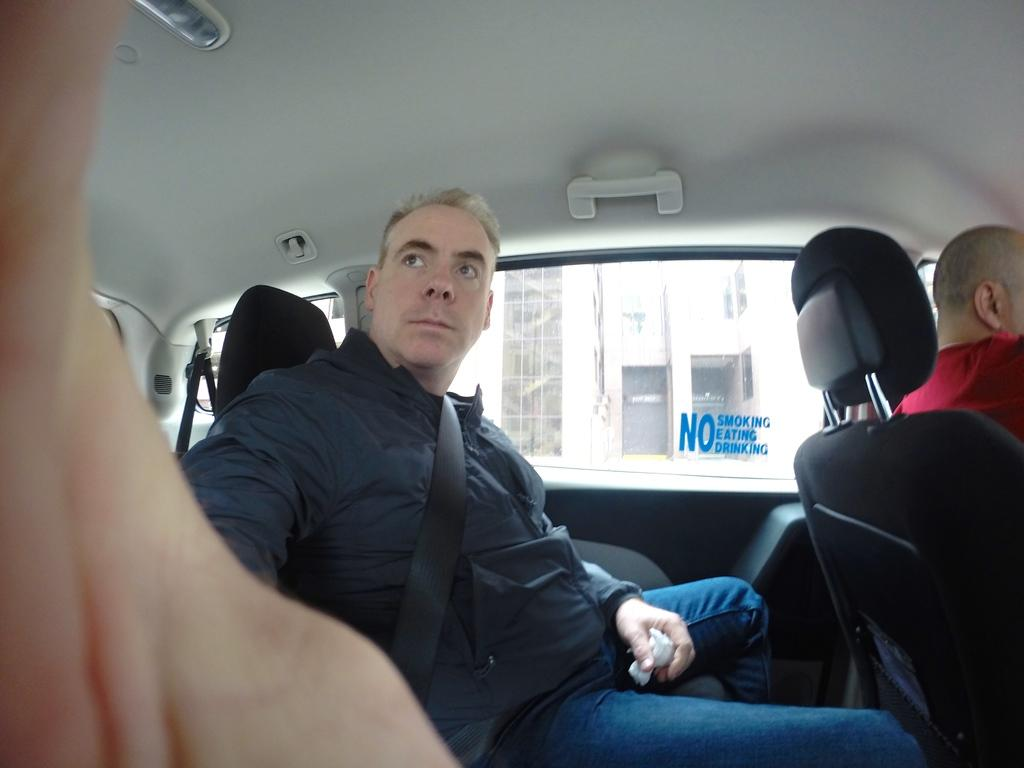Who is present in the image? There is a man in the image. What is the man wearing? The man is wearing a black jacket. What is the man doing in the image? The man is sitting on a car. What can be seen behind the man? There is a glass window behind the man, and a building is visible through it. What type of headphones is the man wearing in the image? There is no mention of headphones in the image; the man is wearing a black jacket. Can you describe the man's wave in the image? There is no wave depicted in the image; the man is sitting on a car. 